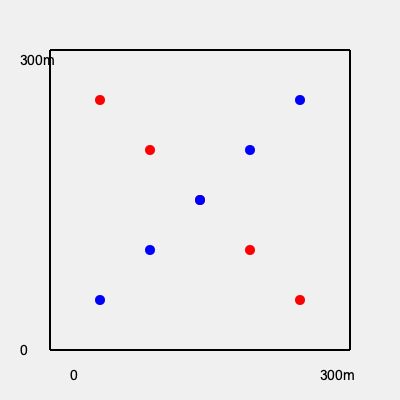Based on the battlefield map shown, which type of formation are the red and blue troops likely utilizing, and what strategic advantage does this formation provide? To analyze the troop formations in this battlefield map, let's follow these steps:

1. Observe the pattern: Both red and blue troops are arranged in diagonal lines.

2. Identify the formation: This diagonal arrangement is known as an "echelon" formation.

3. Understand the echelon formation:
   - An echelon is a step-like arrangement of troops.
   - It can be either right echelon (as seen with the red troops) or left echelon (as seen with the blue troops).

4. Strategic advantages of the echelon formation:
   a) Flexibility: It allows for quick transitions between offensive and defensive postures.
   b) Flank protection: The stepped arrangement provides cover for the flanks of the formation.
   c) Concentrated firepower: Troops can focus their attack on a specific point while maintaining overall formation integrity.
   d) Maneuverability: The formation can easily change direction or pivot around its lead element.

5. In this specific scenario:
   - The red troops are in a right echelon, potentially planning to attack or defend against threats from their right flank.
   - The blue troops are in a left echelon, likely preparing for action on their left flank.

6. The opposing echelons create a potential point of conflict at the center of the map, where both forces meet.

By using the echelon formation, both sides demonstrate an understanding of advanced tactical maneuvers, aiming to maximize their strategic advantages on the battlefield.
Answer: Echelon formation; provides flexibility, flank protection, concentrated firepower, and maneuverability. 